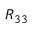<formula> <loc_0><loc_0><loc_500><loc_500>R _ { 3 3 }</formula> 